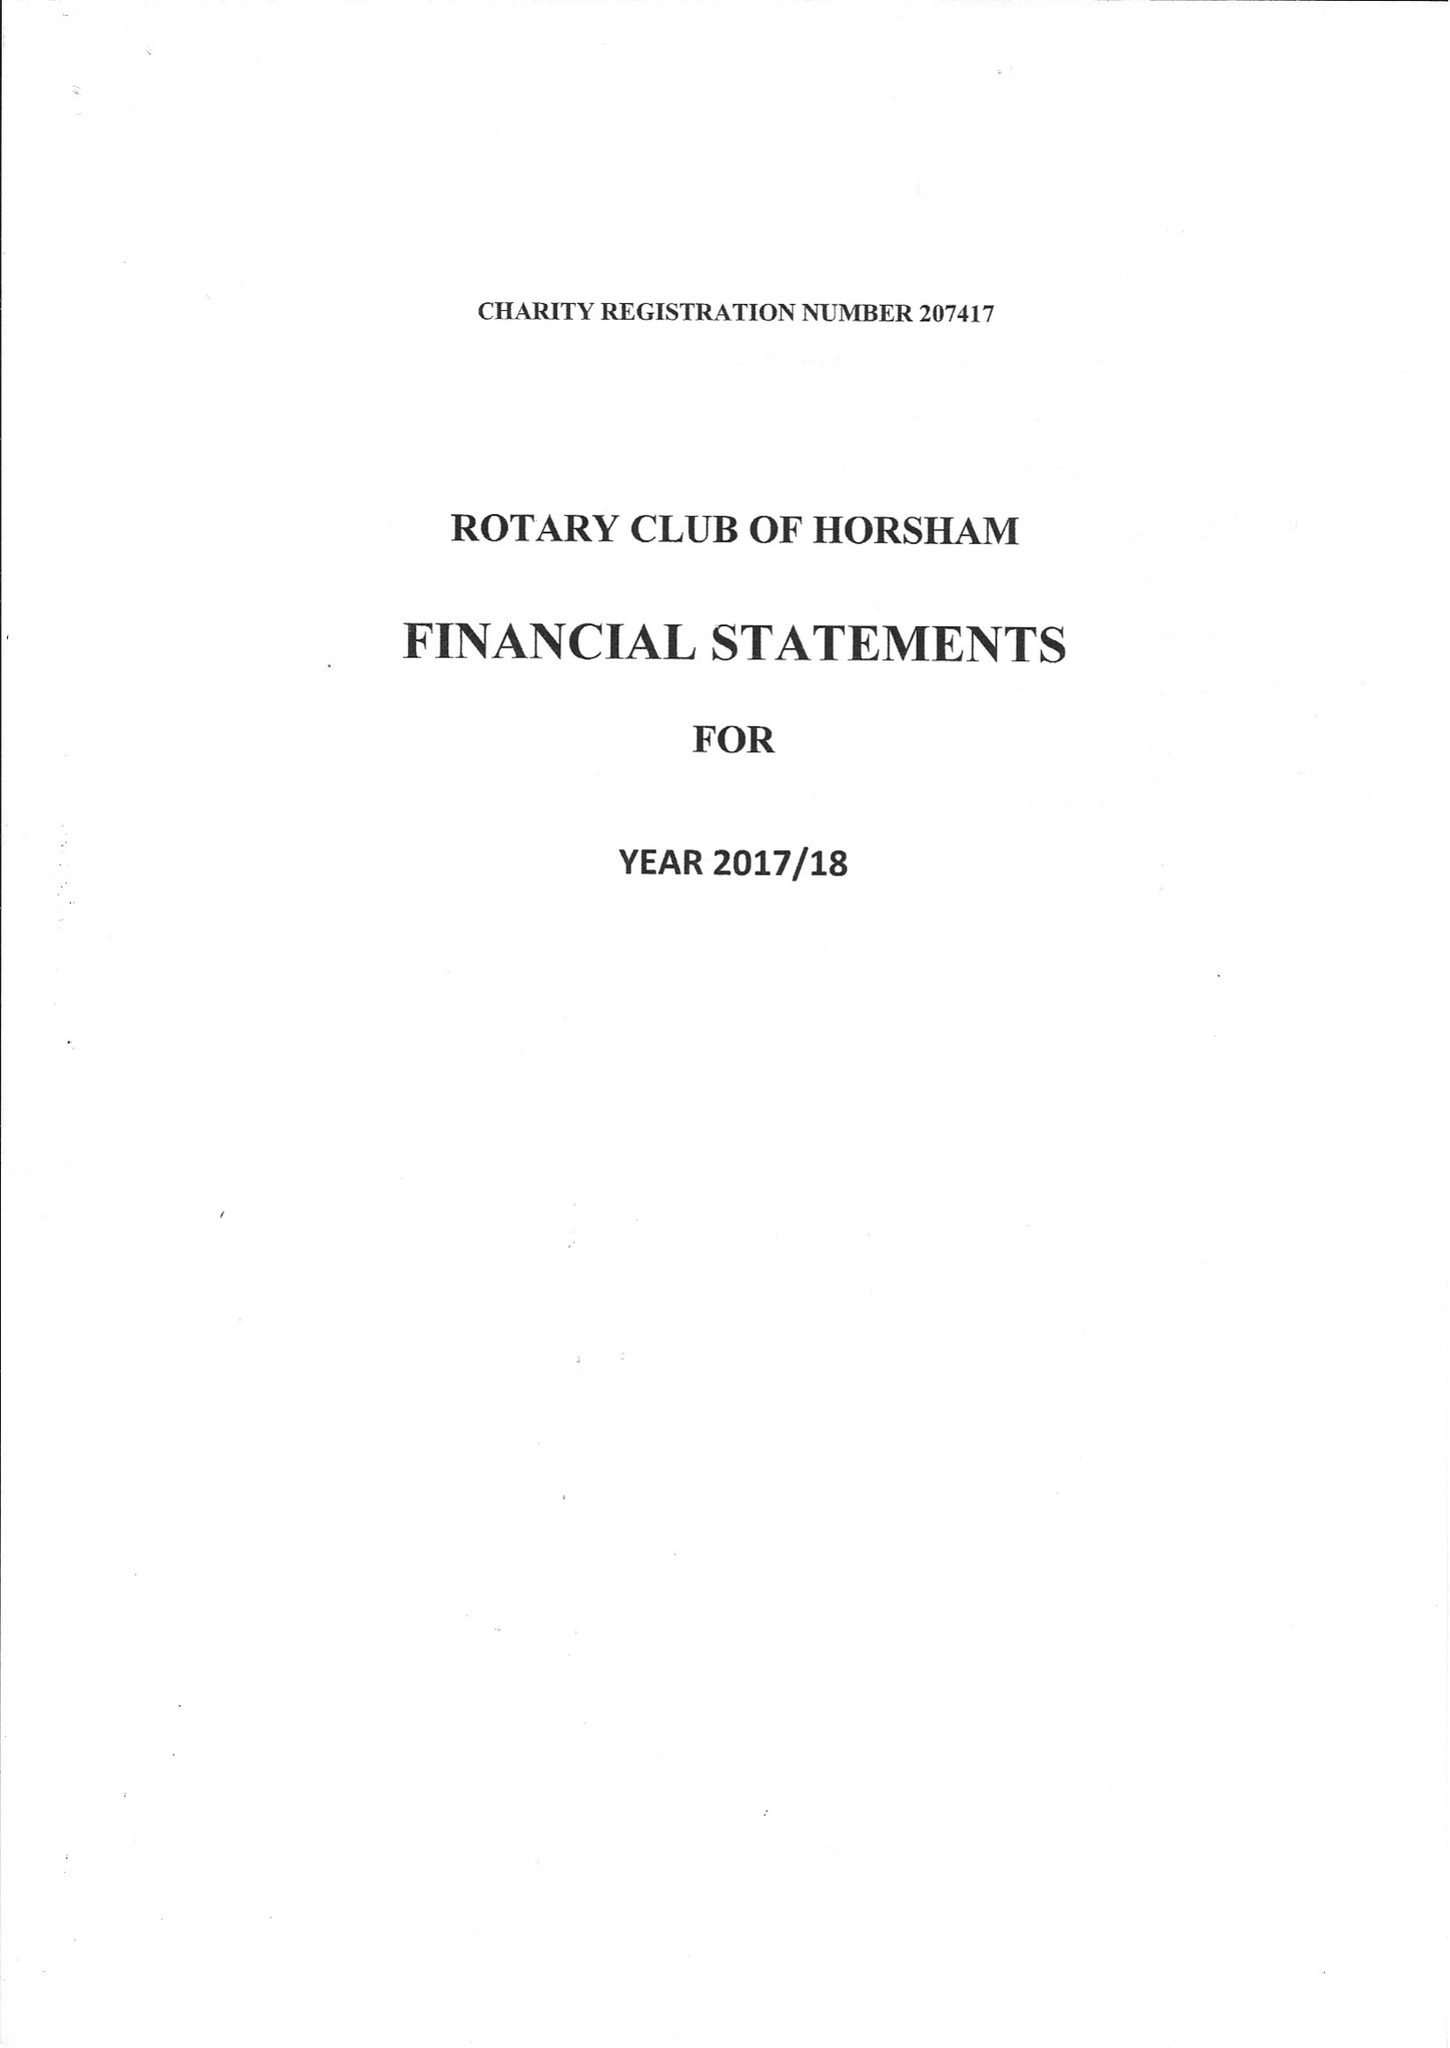What is the value for the charity_number?
Answer the question using a single word or phrase. 207417 